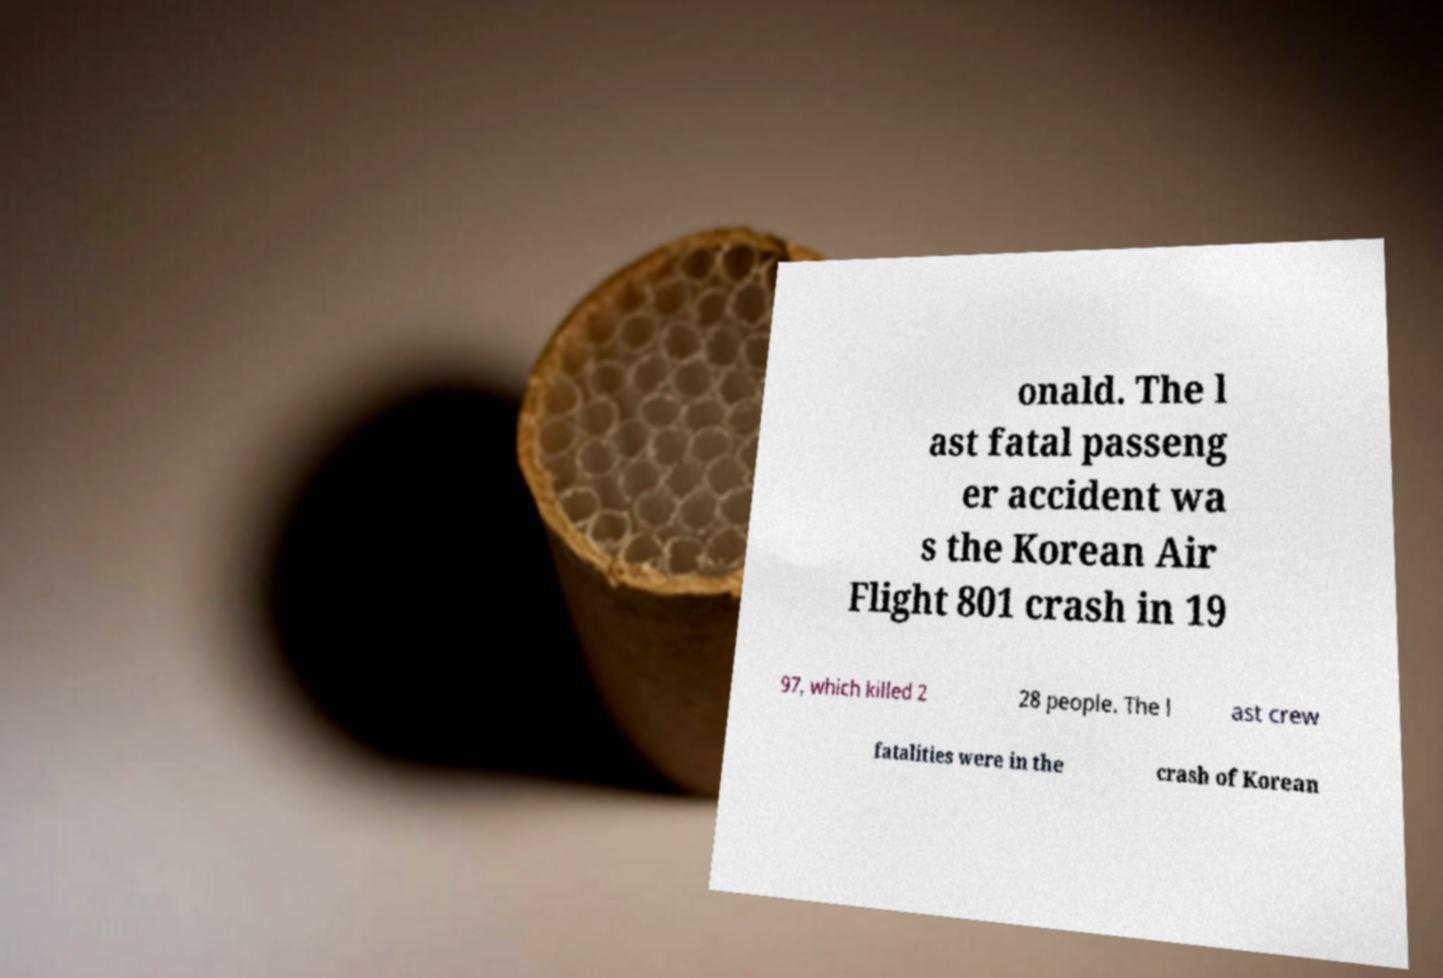Could you assist in decoding the text presented in this image and type it out clearly? onald. The l ast fatal passeng er accident wa s the Korean Air Flight 801 crash in 19 97, which killed 2 28 people. The l ast crew fatalities were in the crash of Korean 